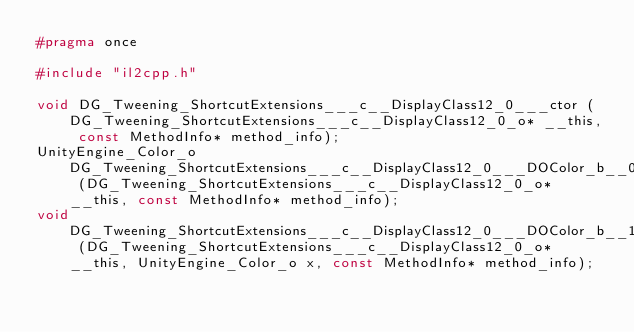Convert code to text. <code><loc_0><loc_0><loc_500><loc_500><_C_>#pragma once

#include "il2cpp.h"

void DG_Tweening_ShortcutExtensions___c__DisplayClass12_0___ctor (DG_Tweening_ShortcutExtensions___c__DisplayClass12_0_o* __this, const MethodInfo* method_info);
UnityEngine_Color_o DG_Tweening_ShortcutExtensions___c__DisplayClass12_0___DOColor_b__0 (DG_Tweening_ShortcutExtensions___c__DisplayClass12_0_o* __this, const MethodInfo* method_info);
void DG_Tweening_ShortcutExtensions___c__DisplayClass12_0___DOColor_b__1 (DG_Tweening_ShortcutExtensions___c__DisplayClass12_0_o* __this, UnityEngine_Color_o x, const MethodInfo* method_info);
</code> 